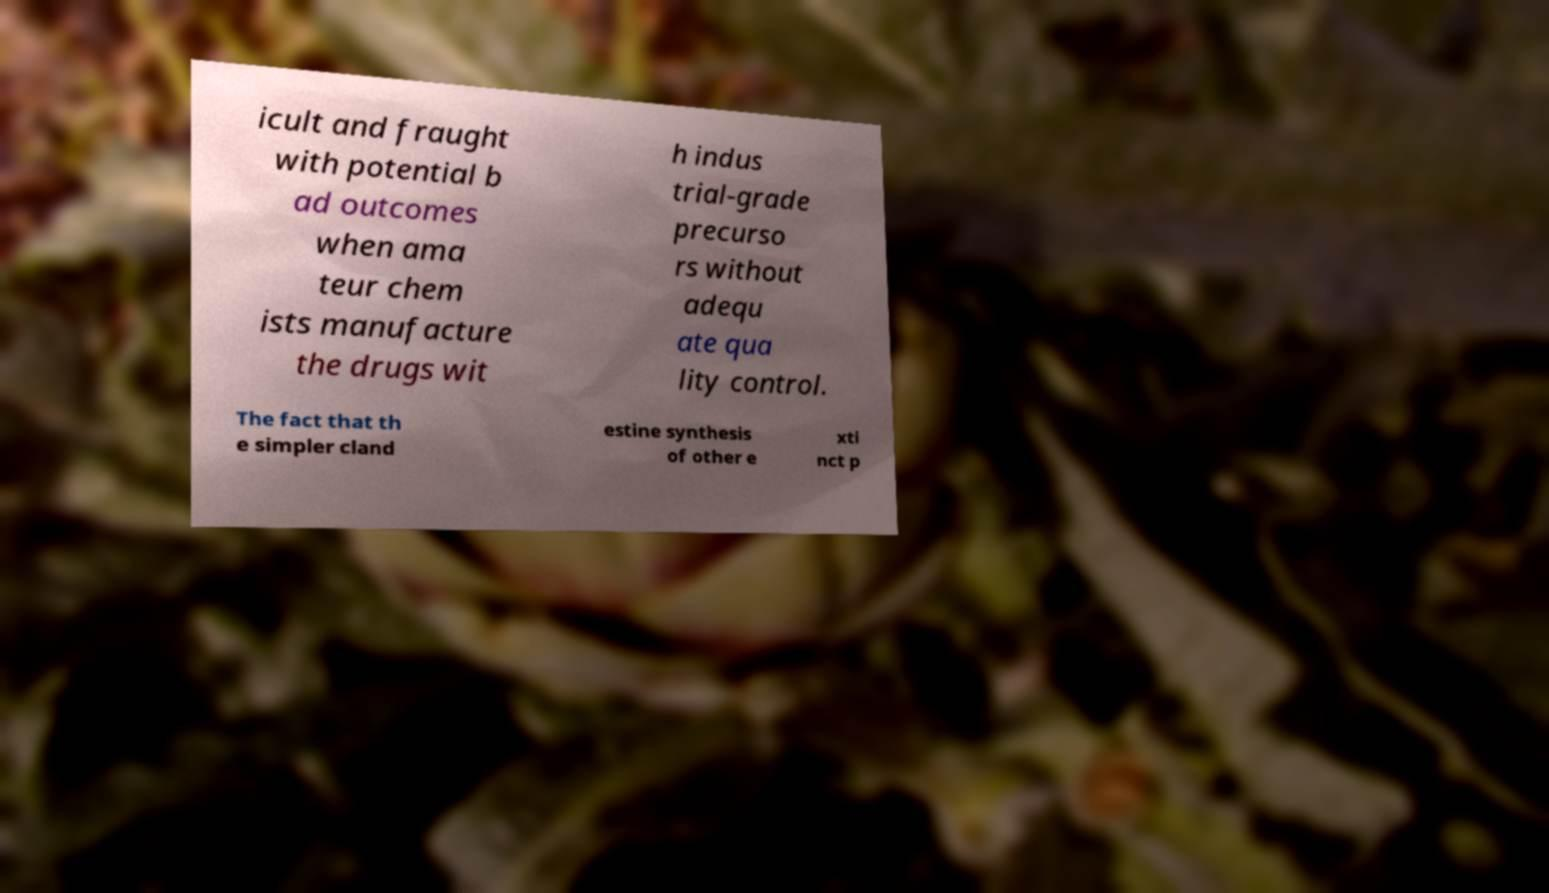Could you assist in decoding the text presented in this image and type it out clearly? icult and fraught with potential b ad outcomes when ama teur chem ists manufacture the drugs wit h indus trial-grade precurso rs without adequ ate qua lity control. The fact that th e simpler cland estine synthesis of other e xti nct p 